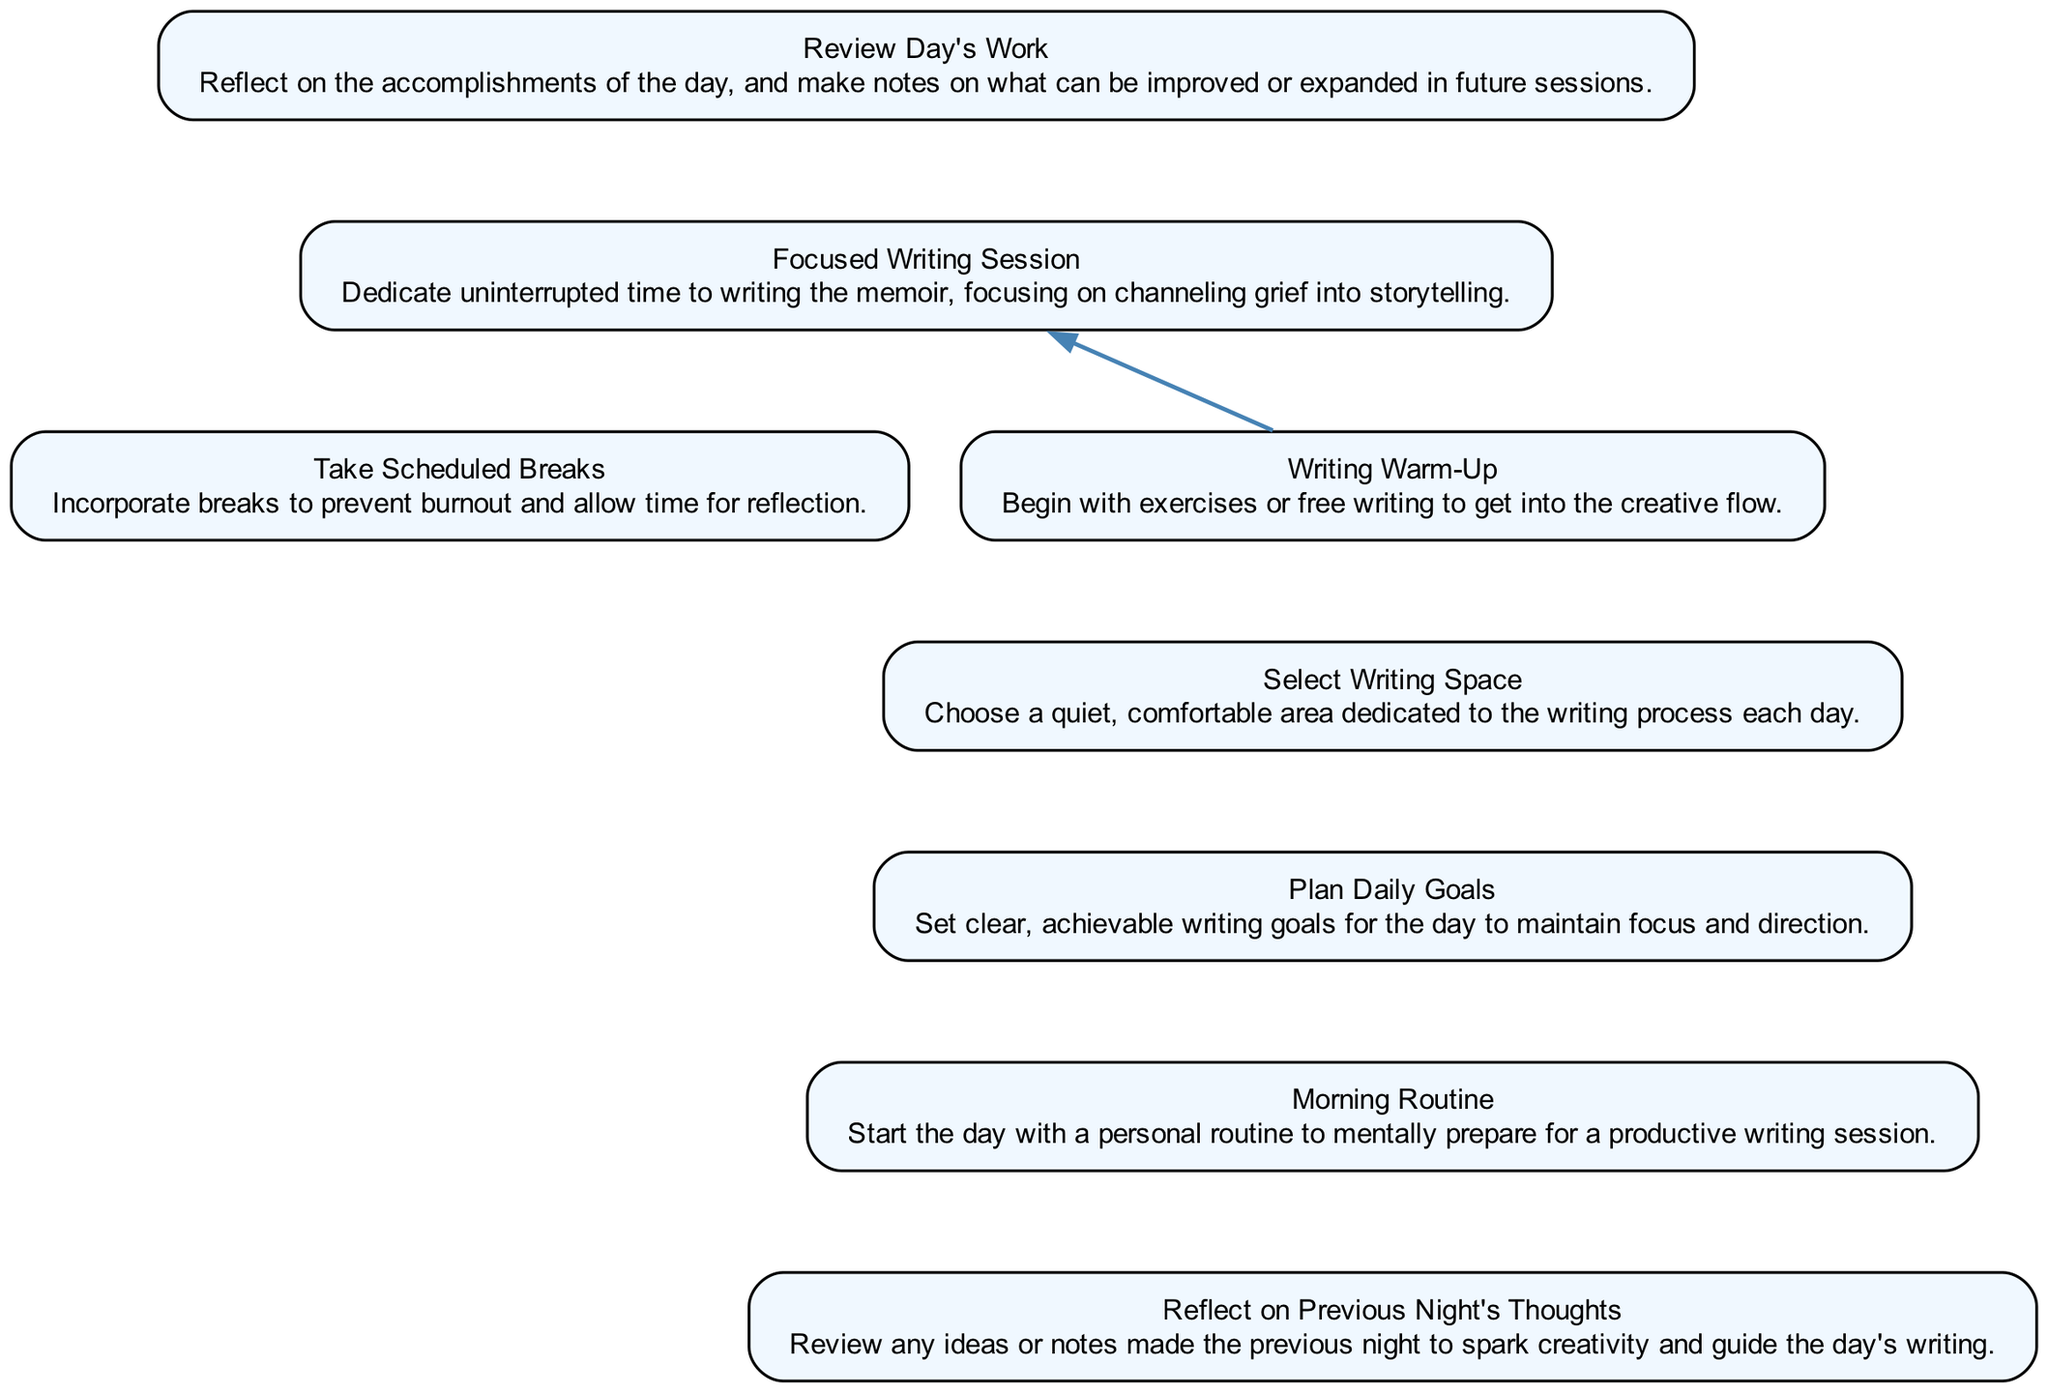What is the last step in the writing routine? The last step is to "Review Day's Work," as it is positioned at the top of the flowchart, indicating it is the concluding task of the routine.
Answer: Review Day's Work How many nodes are in the diagram? By counting each distinct step in the flowchart, we find there are eight nodes that represent different tasks in the writing routine.
Answer: 8 Which step depends on the "Writing Warm-Up"? The "Focused Writing Session" directly relies on the completion of the "Writing Warm-Up," as indicated by the dependency arrow pointing from "Writing Warm-Up" to "Focused Writing Session."
Answer: Focused Writing Session What comes before "Plan Daily Goals"? According to the flow, "Morning Routine" precedes "Plan Daily Goals," as illustrated by the connection from "Morning Routine" to "Plan Daily Goals."
Answer: Morning Routine What is the purpose of taking scheduled breaks? The description in the diagram states that taking scheduled breaks helps to prevent burnout and provides time for reflection, emphasizing its importance within the writing routine.
Answer: Prevent burnout Which two steps are directly connected by an invisible edge? The invisible edge connects "Reflect Night Prior" to "Morning Routine," indicating a flow of thought that guides the day's writing process.
Answer: Reflect Night Prior and Morning Routine What is the starting point of the writing routine? The starting point is "Reflect on Previous Night's Thoughts," which is at the bottom of the diagram and serves as the first task of the daily writing routine.
Answer: Reflect on Previous Night's Thoughts How does "Select Writing Space" relate to "Scheduled Breaks"? Both tasks are part of the overall writing routine, but "Select Writing Space" does not depend on "Scheduled Breaks" and stands alone in the flow, indicating it occurs independently.
Answer: No direct relation Which step directly follows "Focused Writing Session"? The step that directly follows "Focused Writing Session" is "Review Day's Work," as illustrated at the end of the flow leading upward after the writing session.
Answer: Review Day's Work What is outlined in the "Writing Warm-Up"? The "Writing Warm-Up" is outlined as beginning with exercises or free writing to facilitate entering a creative flow, setting the tone for the subsequent focused writing.
Answer: Exercises or free writing 